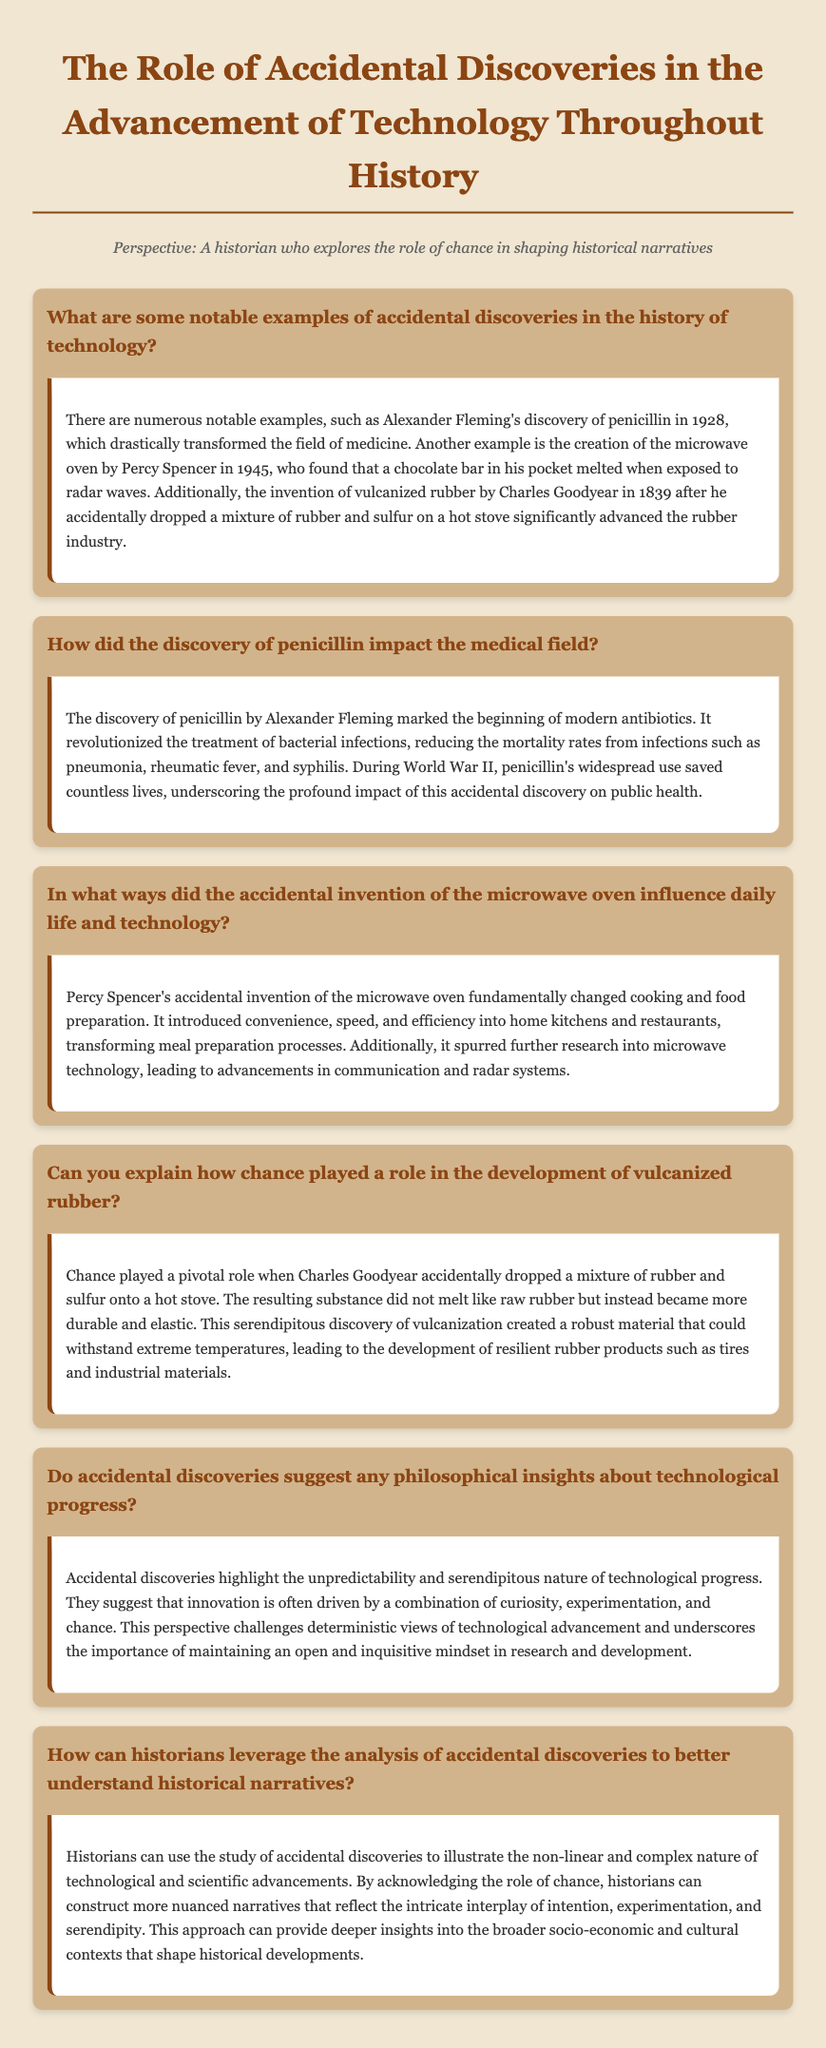What are some notable accidental discoveries mentioned? The document includes examples such as the discovery of penicillin by Alexander Fleming, the creation of the microwave oven by Percy Spencer, and the invention of vulcanized rubber by Charles Goodyear.
Answer: penicillin, microwave oven, vulcanized rubber Who discovered penicillin? The document states that penicillin was discovered by Alexander Fleming in 1928.
Answer: Alexander Fleming In what year was the microwave oven invented? The document indicates that the microwave oven was invented in 1945 by Percy Spencer.
Answer: 1945 What did Charles Goodyear accidentally drop on a hot stove? The document notes that Charles Goodyear accidentally dropped a mixture of rubber and sulfur.
Answer: rubber and sulfur How did penicillin impact the treatment of bacterial infections? According to the document, penicillin revolutionized the treatment, reducing mortality rates from infections such as pneumonia, rheumatic fever, and syphilis.
Answer: revolutionized treatment What philosophical insight do accidental discoveries suggest about technological progress? The document mentions that accidental discoveries highlight the unpredictability and serendipity in technological progress.
Answer: unpredictability and serendipity How can historians use accidental discoveries to understand historical narratives? The document states that historians can construct more nuanced narratives by acknowledging the role of chance in technological advancements.
Answer: construct nuanced narratives 